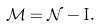<formula> <loc_0><loc_0><loc_500><loc_500>\mathcal { M } = \mathcal { N } - I .</formula> 